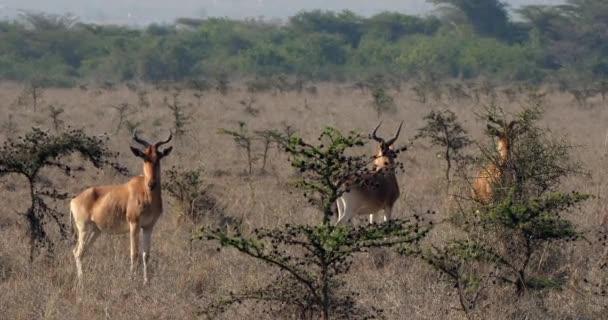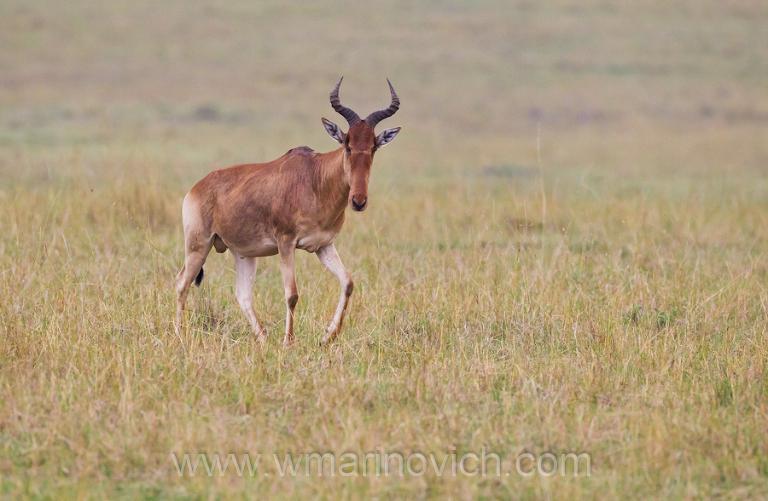The first image is the image on the left, the second image is the image on the right. Assess this claim about the two images: "The left image contains at least three antelopes.". Correct or not? Answer yes or no. Yes. The first image is the image on the left, the second image is the image on the right. For the images shown, is this caption "Three horned animals in standing poses are in the image on the left." true? Answer yes or no. Yes. 